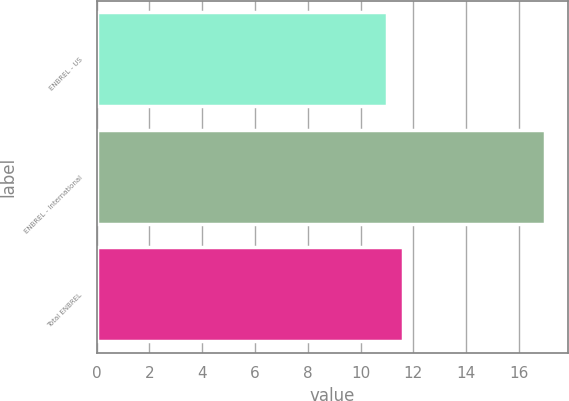<chart> <loc_0><loc_0><loc_500><loc_500><bar_chart><fcel>ENBREL - US<fcel>ENBREL - International<fcel>Total ENBREL<nl><fcel>11<fcel>17<fcel>11.6<nl></chart> 